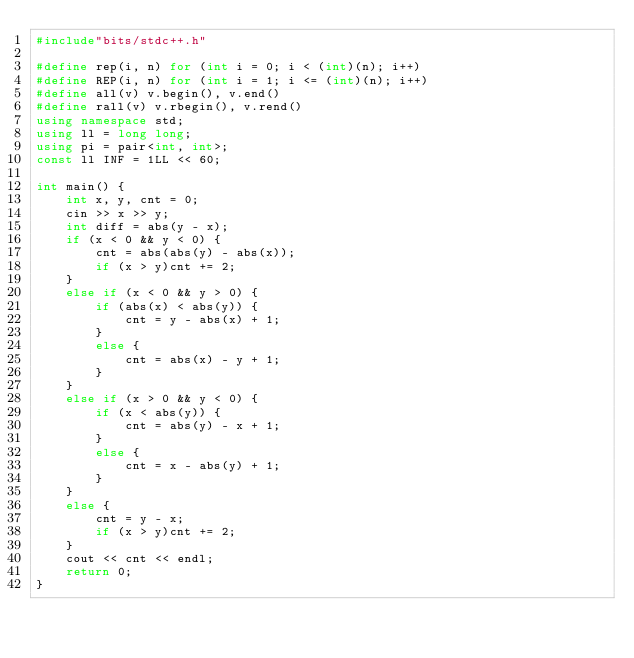<code> <loc_0><loc_0><loc_500><loc_500><_C++_>#include"bits/stdc++.h"

#define rep(i, n) for (int i = 0; i < (int)(n); i++)
#define REP(i, n) for (int i = 1; i <= (int)(n); i++)
#define all(v) v.begin(), v.end()
#define rall(v) v.rbegin(), v.rend()
using namespace std;
using ll = long long;
using pi = pair<int, int>;
const ll INF = 1LL << 60;

int main() {
	int x, y, cnt = 0;
	cin >> x >> y;
	int diff = abs(y - x);
	if (x < 0 && y < 0) {
		cnt = abs(abs(y) - abs(x));
		if (x > y)cnt += 2;
	}
	else if (x < 0 && y > 0) {
		if (abs(x) < abs(y)) {
			cnt = y - abs(x) + 1;
		}
		else {
			cnt = abs(x) - y + 1;
		}
	}
	else if (x > 0 && y < 0) {
		if (x < abs(y)) {
			cnt = abs(y) - x + 1;
		}
		else {
			cnt = x - abs(y) + 1;
		}
	}
	else {
		cnt = y - x;
		if (x > y)cnt += 2;
	}
	cout << cnt << endl;
	return 0;
}

</code> 